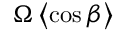<formula> <loc_0><loc_0><loc_500><loc_500>\Omega \left \langle \cos \beta \right \rangle</formula> 